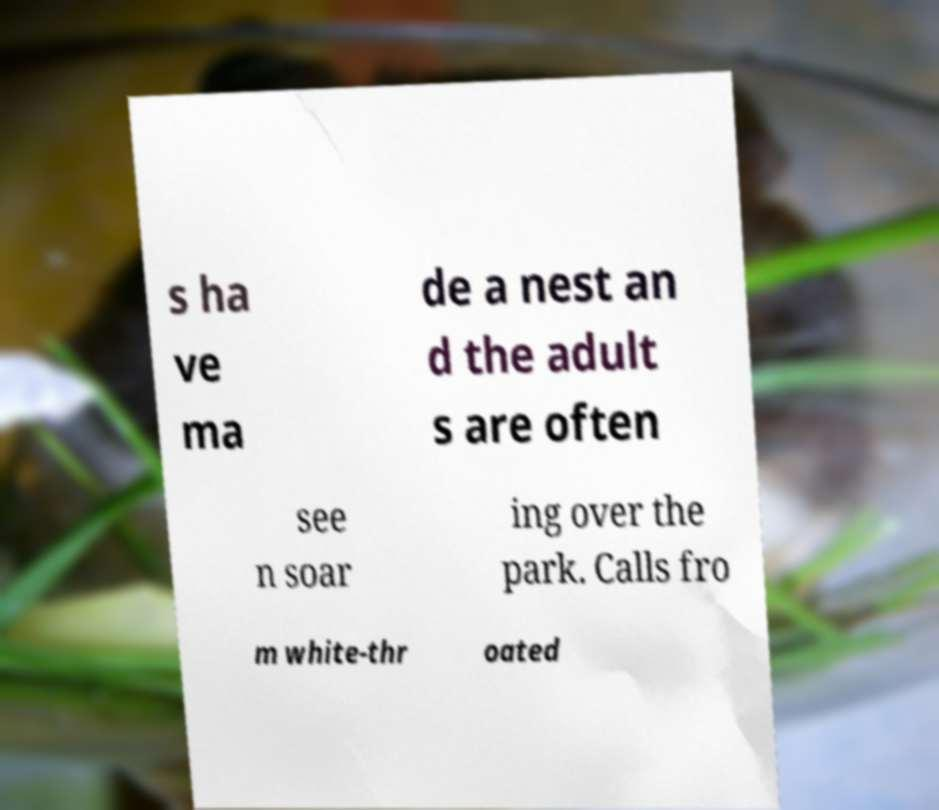Please read and relay the text visible in this image. What does it say? s ha ve ma de a nest an d the adult s are often see n soar ing over the park. Calls fro m white-thr oated 